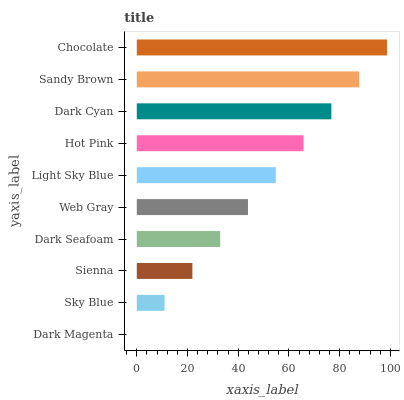Is Dark Magenta the minimum?
Answer yes or no. Yes. Is Chocolate the maximum?
Answer yes or no. Yes. Is Sky Blue the minimum?
Answer yes or no. No. Is Sky Blue the maximum?
Answer yes or no. No. Is Sky Blue greater than Dark Magenta?
Answer yes or no. Yes. Is Dark Magenta less than Sky Blue?
Answer yes or no. Yes. Is Dark Magenta greater than Sky Blue?
Answer yes or no. No. Is Sky Blue less than Dark Magenta?
Answer yes or no. No. Is Light Sky Blue the high median?
Answer yes or no. Yes. Is Web Gray the low median?
Answer yes or no. Yes. Is Chocolate the high median?
Answer yes or no. No. Is Dark Seafoam the low median?
Answer yes or no. No. 